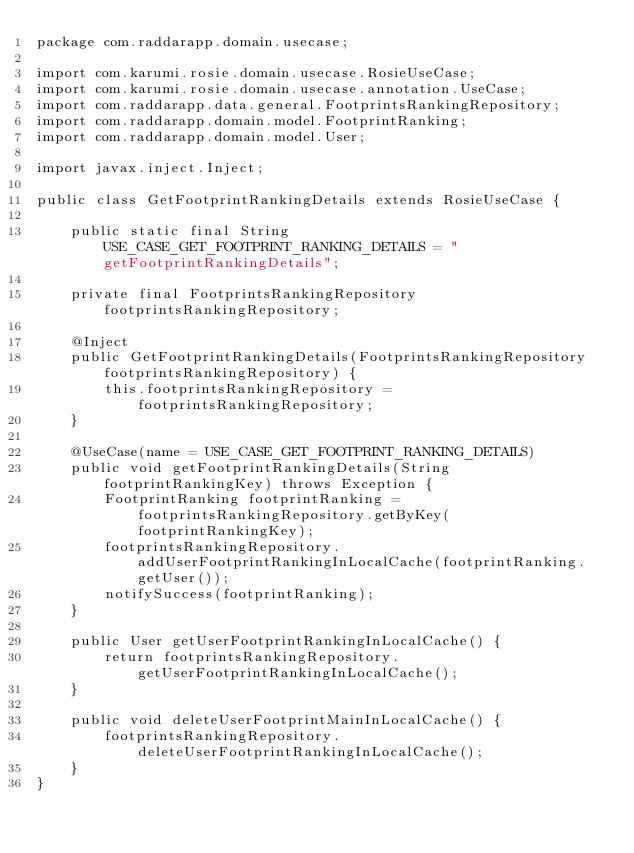<code> <loc_0><loc_0><loc_500><loc_500><_Java_>package com.raddarapp.domain.usecase;

import com.karumi.rosie.domain.usecase.RosieUseCase;
import com.karumi.rosie.domain.usecase.annotation.UseCase;
import com.raddarapp.data.general.FootprintsRankingRepository;
import com.raddarapp.domain.model.FootprintRanking;
import com.raddarapp.domain.model.User;

import javax.inject.Inject;

public class GetFootprintRankingDetails extends RosieUseCase {

    public static final String USE_CASE_GET_FOOTPRINT_RANKING_DETAILS = "getFootprintRankingDetails";

    private final FootprintsRankingRepository footprintsRankingRepository;

    @Inject
    public GetFootprintRankingDetails(FootprintsRankingRepository footprintsRankingRepository) {
        this.footprintsRankingRepository = footprintsRankingRepository;
    }

    @UseCase(name = USE_CASE_GET_FOOTPRINT_RANKING_DETAILS)
    public void getFootprintRankingDetails(String footprintRankingKey) throws Exception {
        FootprintRanking footprintRanking = footprintsRankingRepository.getByKey(footprintRankingKey);
        footprintsRankingRepository.addUserFootprintRankingInLocalCache(footprintRanking.getUser());
        notifySuccess(footprintRanking);
    }

    public User getUserFootprintRankingInLocalCache() {
        return footprintsRankingRepository.getUserFootprintRankingInLocalCache();
    }

    public void deleteUserFootprintMainInLocalCache() {
        footprintsRankingRepository.deleteUserFootprintRankingInLocalCache();
    }
}
</code> 